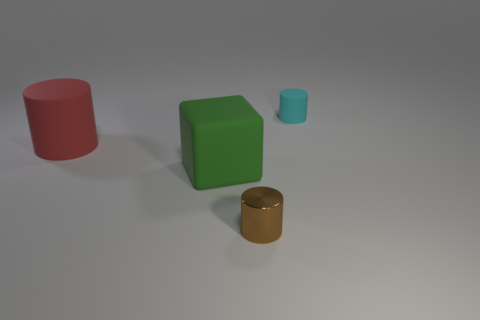Subtract all cyan rubber cylinders. How many cylinders are left? 2 Subtract all cyan cylinders. How many cylinders are left? 2 Add 1 small brown cylinders. How many objects exist? 5 Subtract all cylinders. How many objects are left? 1 Subtract 2 cylinders. How many cylinders are left? 1 Subtract all cyan spheres. How many cyan cylinders are left? 1 Add 4 large red matte things. How many large red matte things are left? 5 Add 2 cyan cylinders. How many cyan cylinders exist? 3 Subtract 0 yellow cubes. How many objects are left? 4 Subtract all green cylinders. Subtract all gray balls. How many cylinders are left? 3 